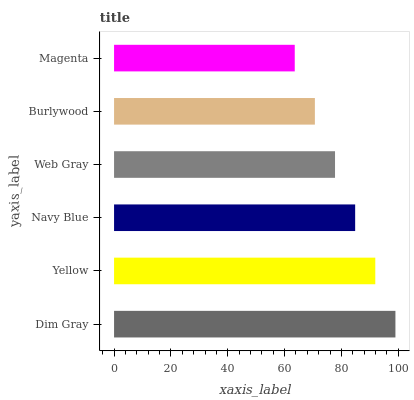Is Magenta the minimum?
Answer yes or no. Yes. Is Dim Gray the maximum?
Answer yes or no. Yes. Is Yellow the minimum?
Answer yes or no. No. Is Yellow the maximum?
Answer yes or no. No. Is Dim Gray greater than Yellow?
Answer yes or no. Yes. Is Yellow less than Dim Gray?
Answer yes or no. Yes. Is Yellow greater than Dim Gray?
Answer yes or no. No. Is Dim Gray less than Yellow?
Answer yes or no. No. Is Navy Blue the high median?
Answer yes or no. Yes. Is Web Gray the low median?
Answer yes or no. Yes. Is Yellow the high median?
Answer yes or no. No. Is Burlywood the low median?
Answer yes or no. No. 